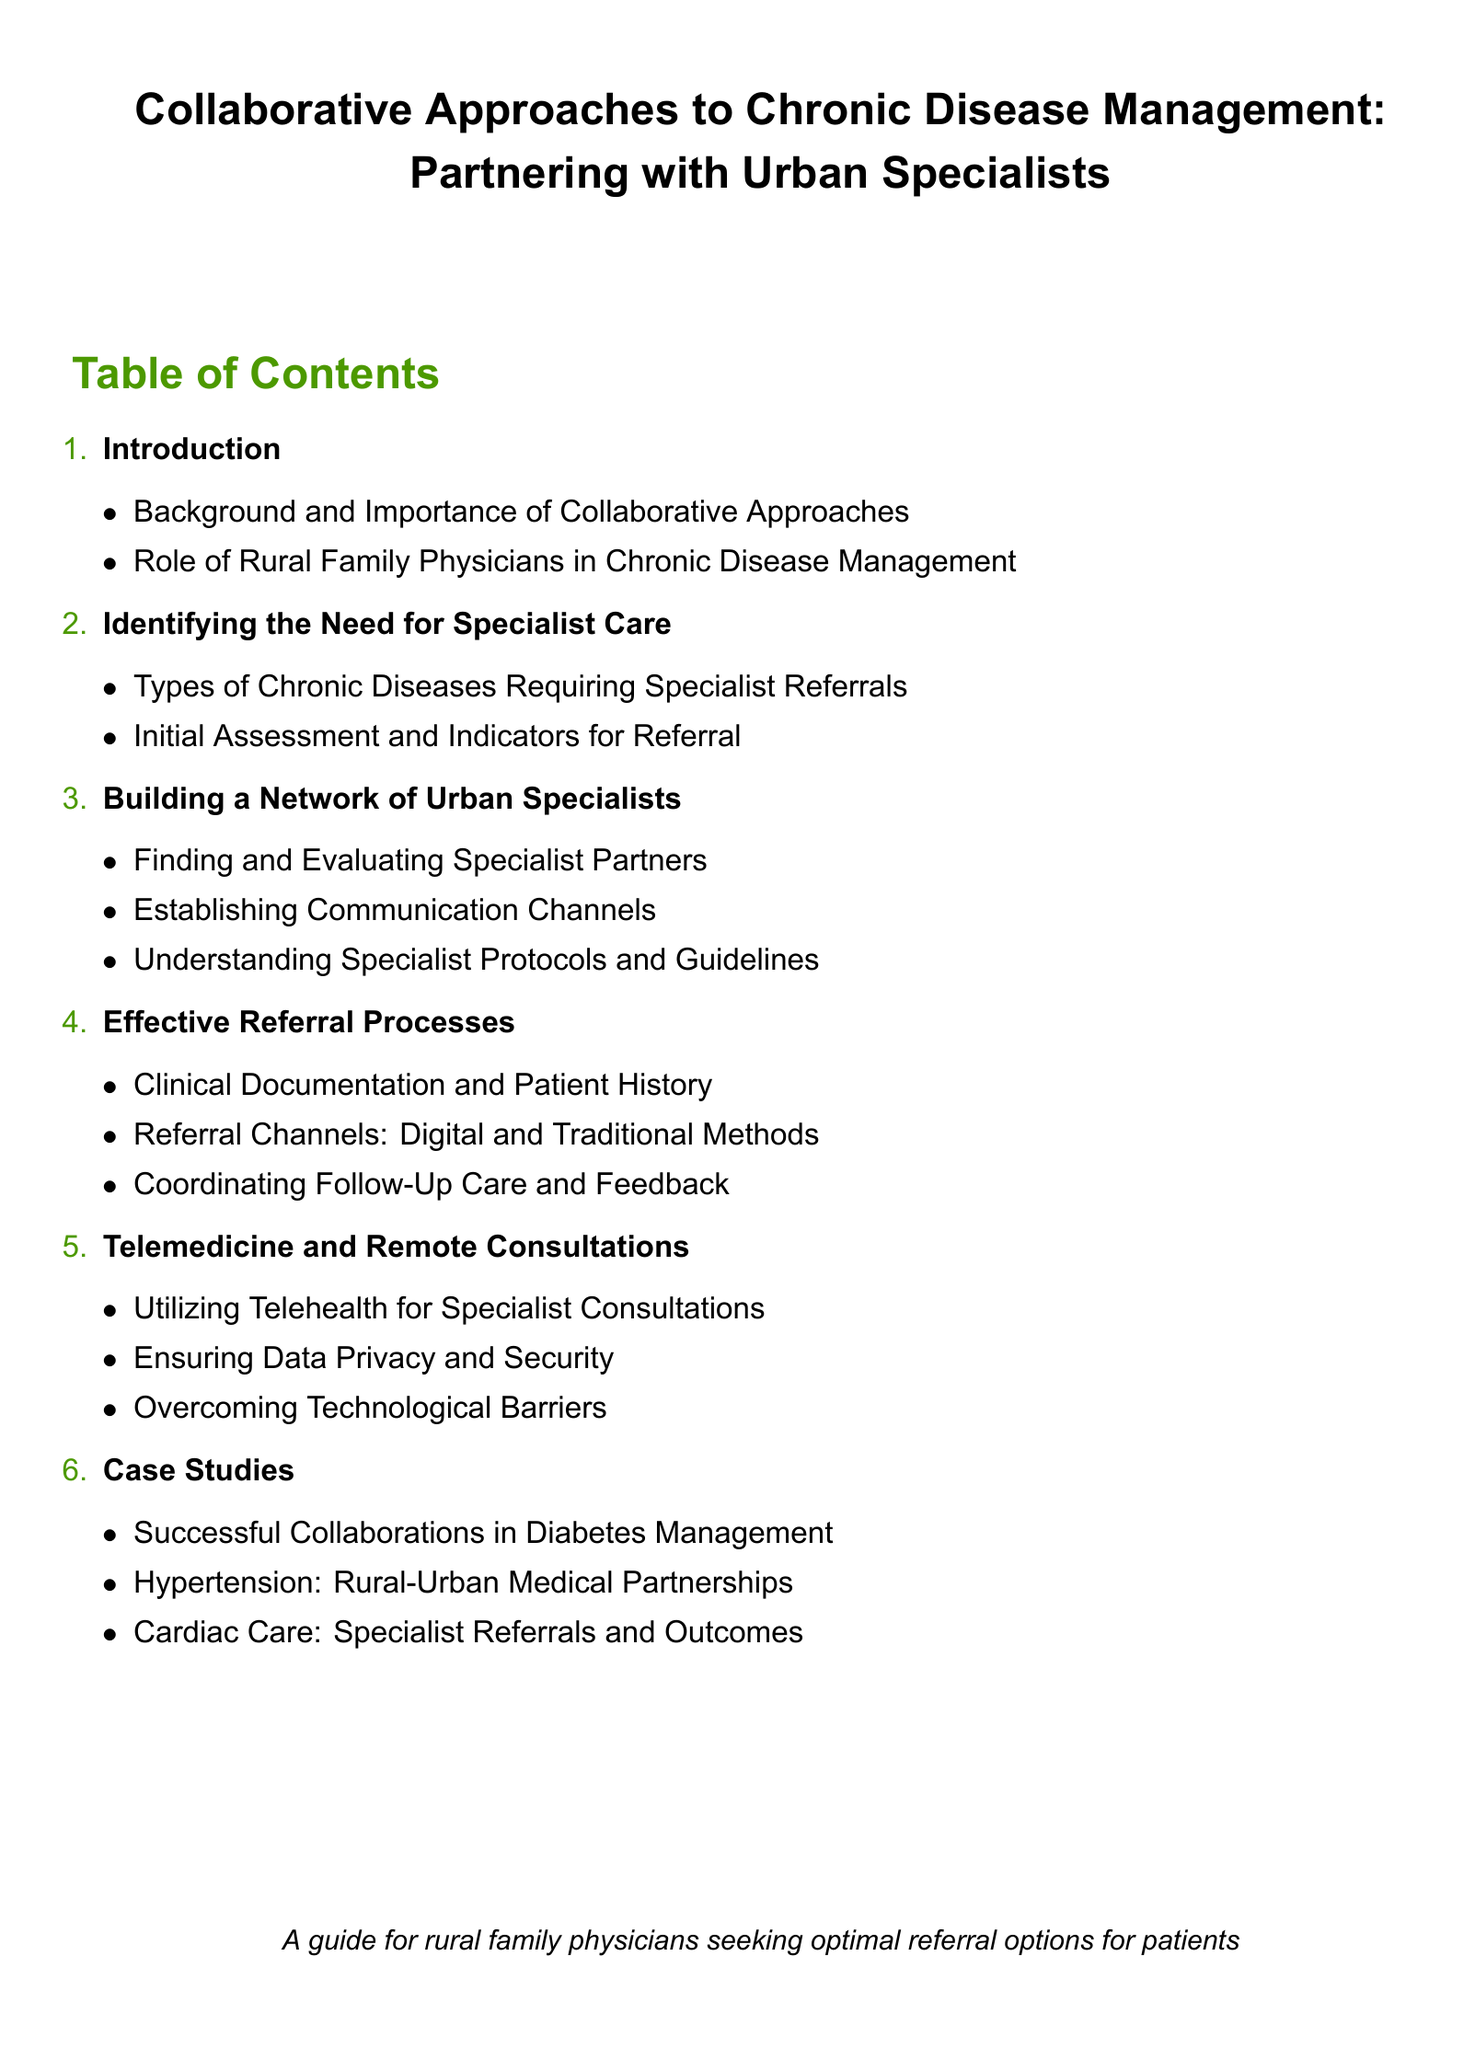what is the title of the document? The title is "Collaborative Approaches to Chronic Disease Management: Partnering with Urban Specialists."
Answer: Collaborative Approaches to Chronic Disease Management: Partnering with Urban Specialists how many sections are there in the Table of Contents? There are six main sections listed in the Table of Contents.
Answer: 6 what is the focus of section 2? Section 2 is focused on identifying the need for specialist care, including types of chronic diseases and referral indicators.
Answer: Identifying the Need for Specialist Care what is one example of a chronic disease mentioned for specialist referrals? The document references diabetes management as a chronic disease needing specialist referrals.
Answer: Diabetes what is the color used for section headings? The section headings are colored rural green.
Answer: rural green what is a method mentioned for consultations in section 5? Section 5 mentions utilizing telehealth for specialist consultations.
Answer: Telehealth which section discusses effective referral processes? Section 4 specifically discusses effective referral processes.
Answer: Effective Referral Processes name one topic covered under the case studies section. The document mentions hypertension as one of the topics covered in the case studies.
Answer: Hypertension 